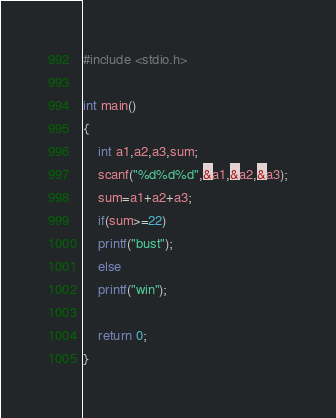Convert code to text. <code><loc_0><loc_0><loc_500><loc_500><_Awk_>#include <stdio.h>

int main()
{
    int a1,a2,a3,sum;
    scanf("%d%d%d",&a1,&a2,&a3);
    sum=a1+a2+a3;
    if(sum>=22)
    printf("bust");
    else
    printf("win");

    return 0;
}</code> 